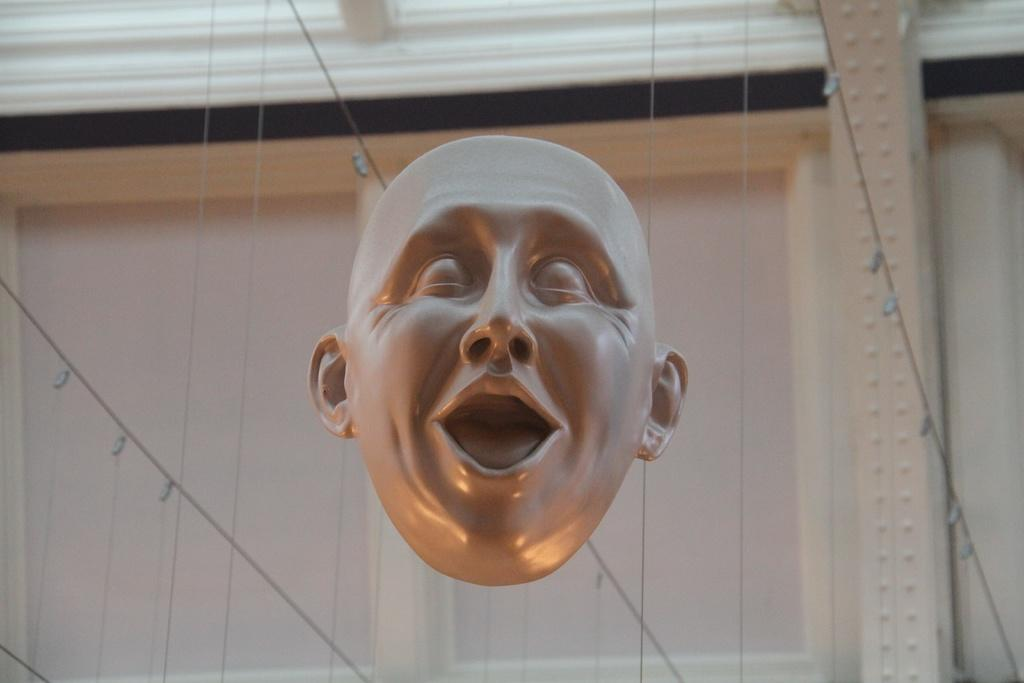What is the main subject of the image? There is a mask of a person's face in the image. Are there any additional features on the mask? Yes, there are strings behind the mask. What can be seen on the wall in the image? There is a window on the wall in the image. What type of butter is being used to make the mask in the image? There is no butter present in the image, as it features a mask of a person's face with strings behind it and a window on the wall. What kind of apparel is the person wearing in the image? The image does not show a person wearing any apparel; it only features a mask of a person's face with strings behind it and a window on the wall. 